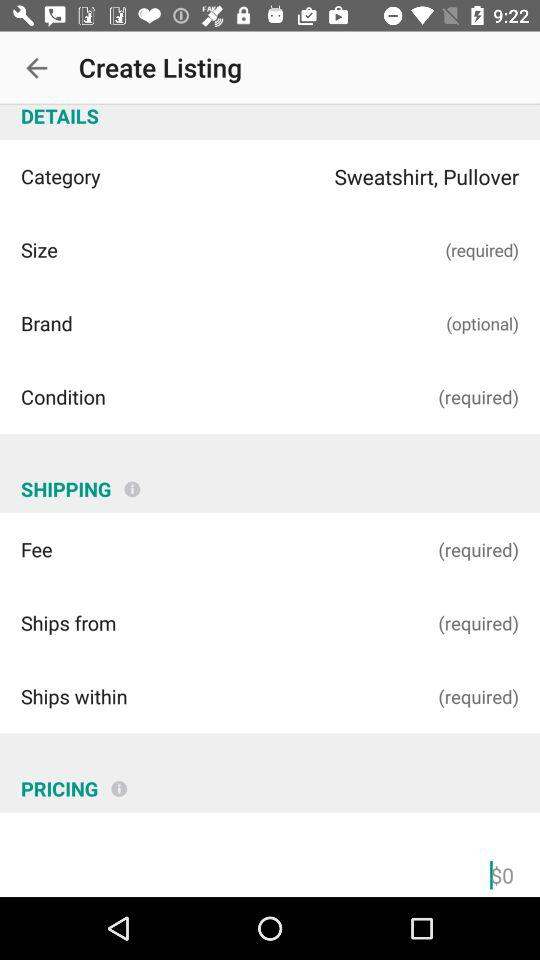What category has been selected? The category that has been selected is "Sweatshirt, Pullover". 